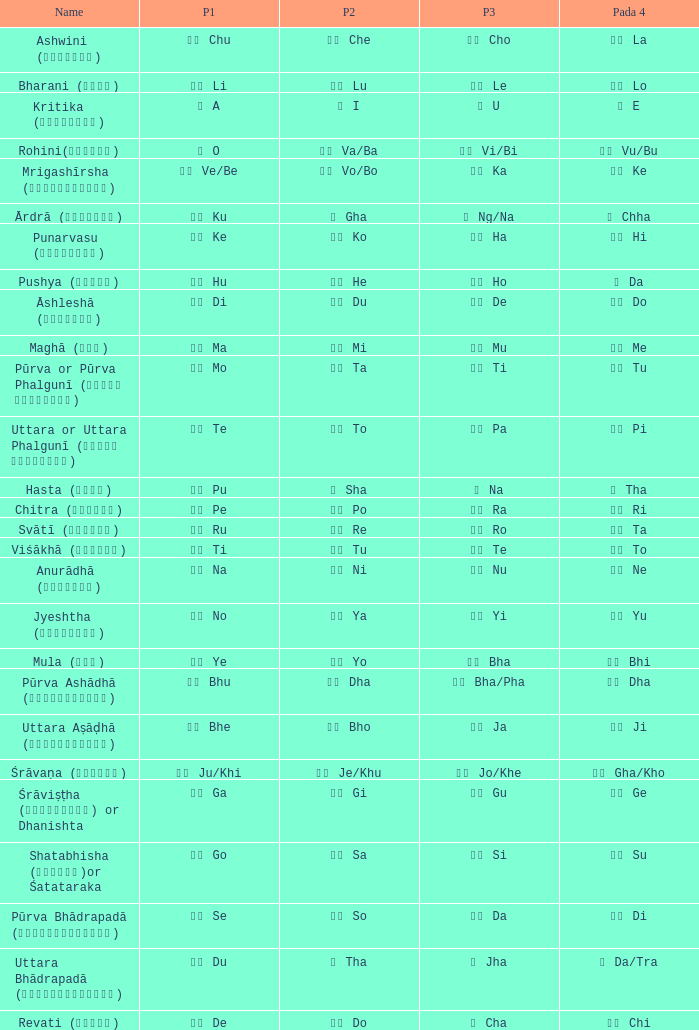What is the Name of ङ ng/na? Ārdrā (आर्द्रा). 